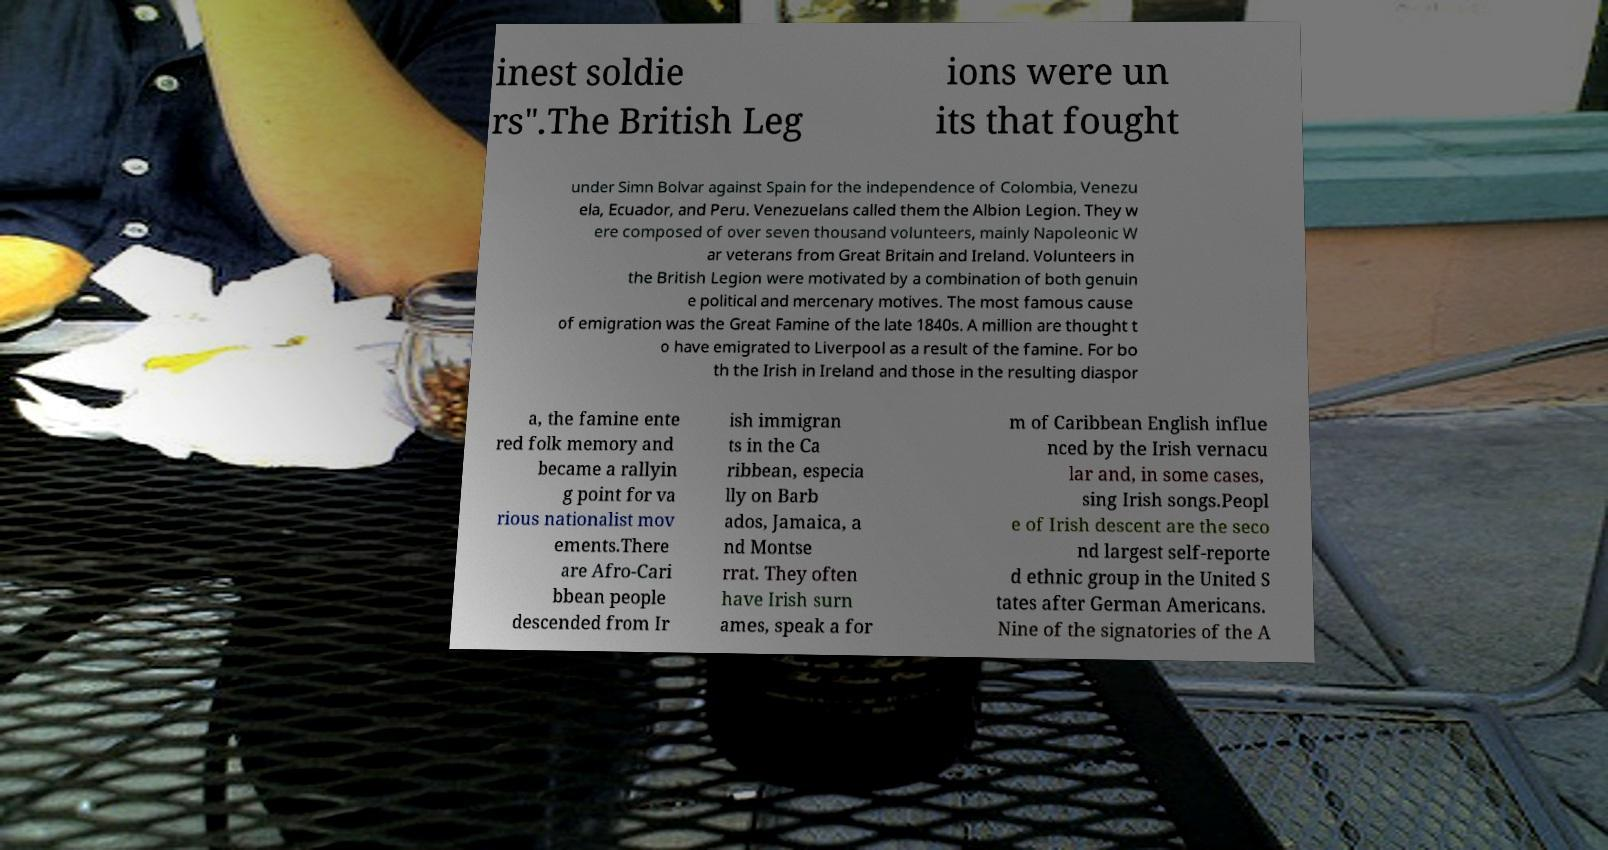Please identify and transcribe the text found in this image. inest soldie rs".The British Leg ions were un its that fought under Simn Bolvar against Spain for the independence of Colombia, Venezu ela, Ecuador, and Peru. Venezuelans called them the Albion Legion. They w ere composed of over seven thousand volunteers, mainly Napoleonic W ar veterans from Great Britain and Ireland. Volunteers in the British Legion were motivated by a combination of both genuin e political and mercenary motives. The most famous cause of emigration was the Great Famine of the late 1840s. A million are thought t o have emigrated to Liverpool as a result of the famine. For bo th the Irish in Ireland and those in the resulting diaspor a, the famine ente red folk memory and became a rallyin g point for va rious nationalist mov ements.There are Afro-Cari bbean people descended from Ir ish immigran ts in the Ca ribbean, especia lly on Barb ados, Jamaica, a nd Montse rrat. They often have Irish surn ames, speak a for m of Caribbean English influe nced by the Irish vernacu lar and, in some cases, sing Irish songs.Peopl e of Irish descent are the seco nd largest self-reporte d ethnic group in the United S tates after German Americans. Nine of the signatories of the A 